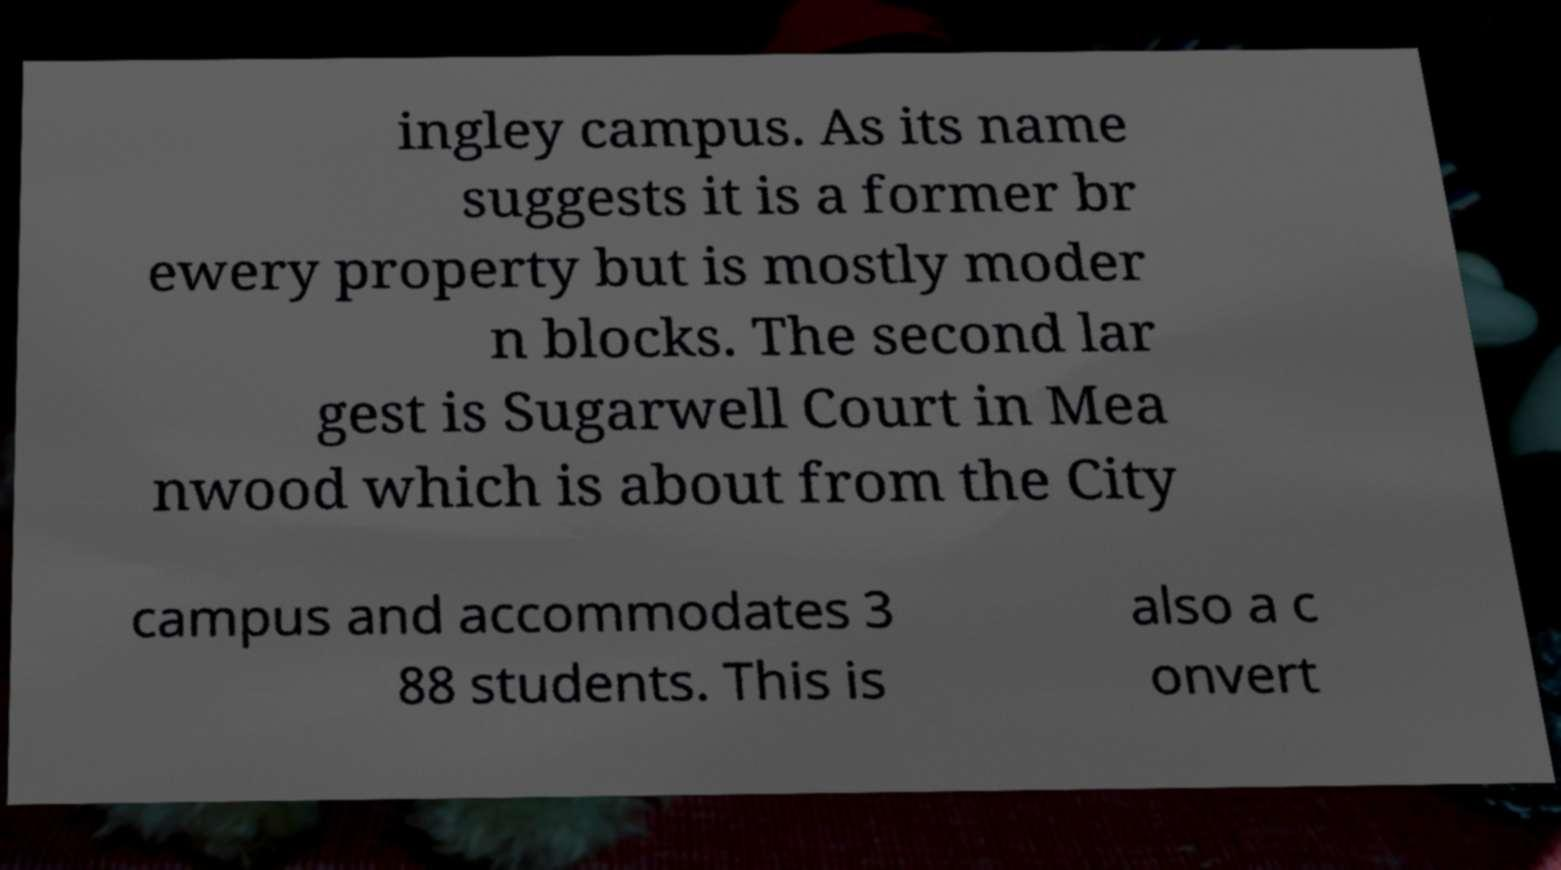Please identify and transcribe the text found in this image. ingley campus. As its name suggests it is a former br ewery property but is mostly moder n blocks. The second lar gest is Sugarwell Court in Mea nwood which is about from the City campus and accommodates 3 88 students. This is also a c onvert 